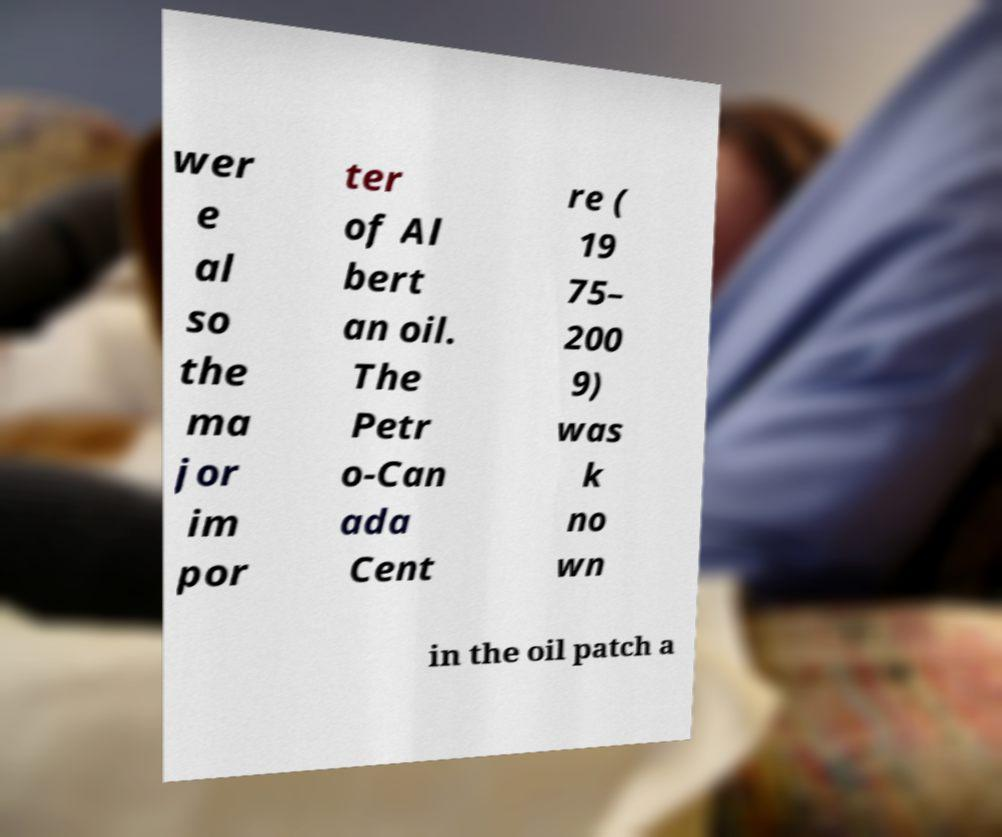I need the written content from this picture converted into text. Can you do that? wer e al so the ma jor im por ter of Al bert an oil. The Petr o-Can ada Cent re ( 19 75– 200 9) was k no wn in the oil patch a 